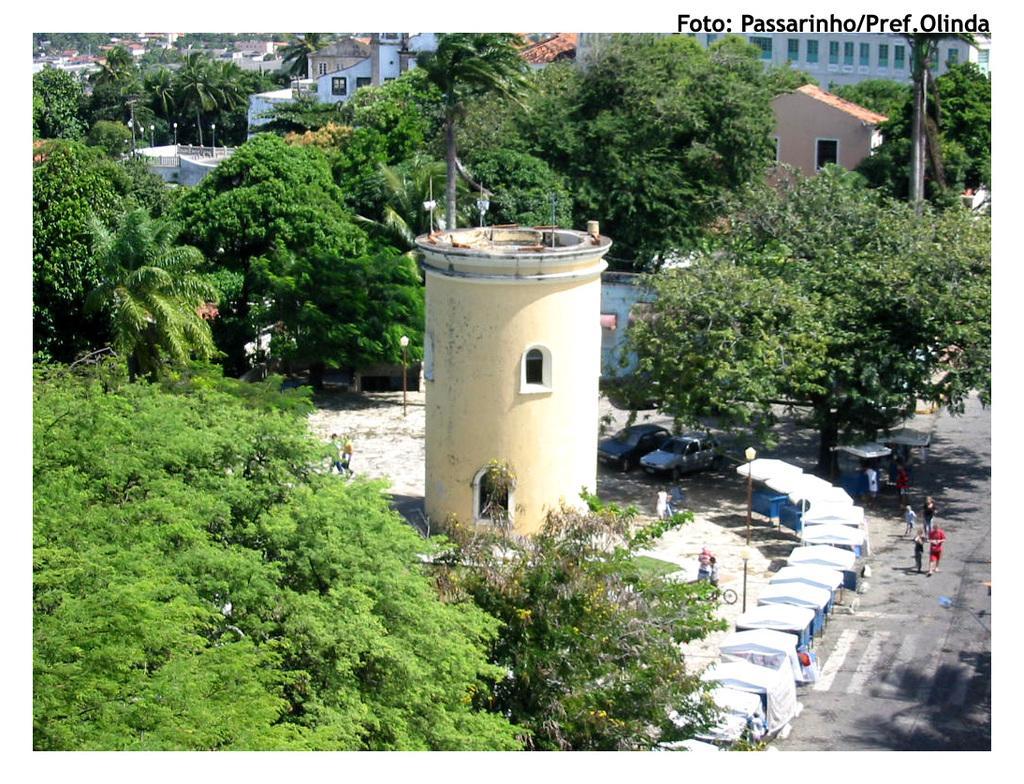Please provide a concise description of this image. In the picture we can see a huge pillar construction with some windows to it and besides it, we can see trees and on the other side, we can see some white color shades and beside it, we can see a road with zebra lines and some people are walking on it and in the background we can see many trees, houses, buildings. 